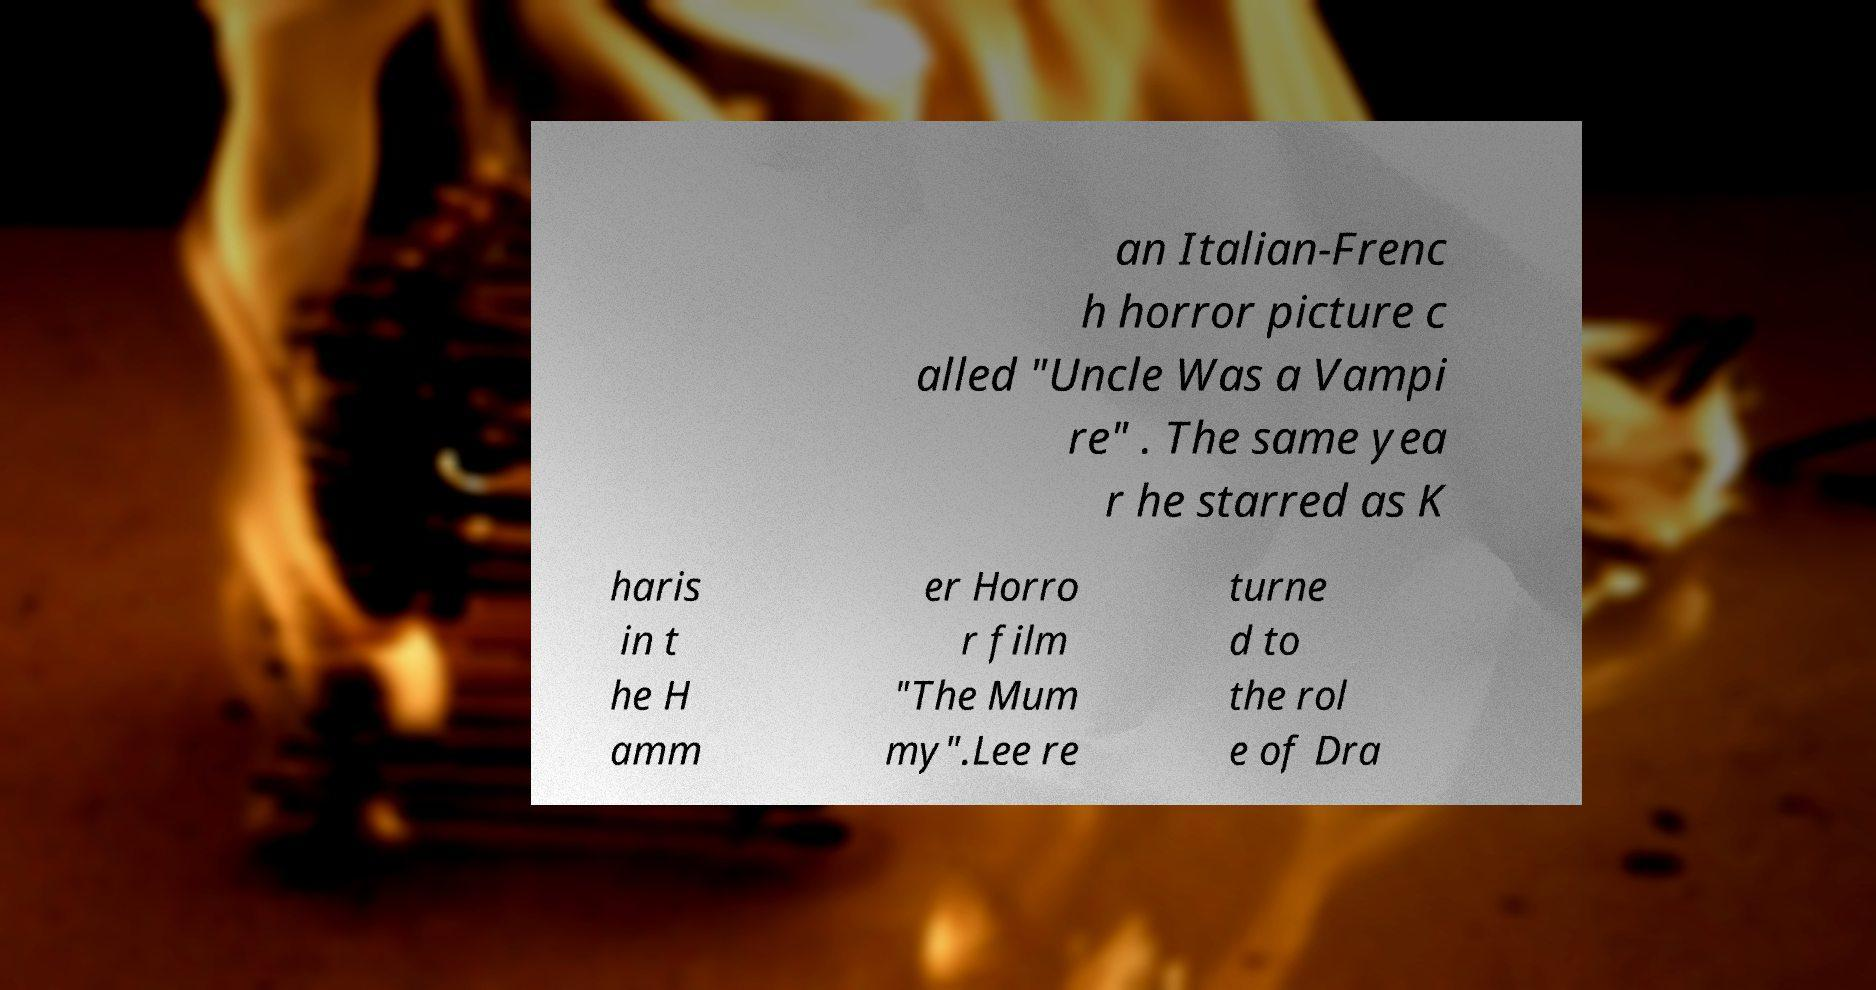There's text embedded in this image that I need extracted. Can you transcribe it verbatim? an Italian-Frenc h horror picture c alled "Uncle Was a Vampi re" . The same yea r he starred as K haris in t he H amm er Horro r film "The Mum my".Lee re turne d to the rol e of Dra 